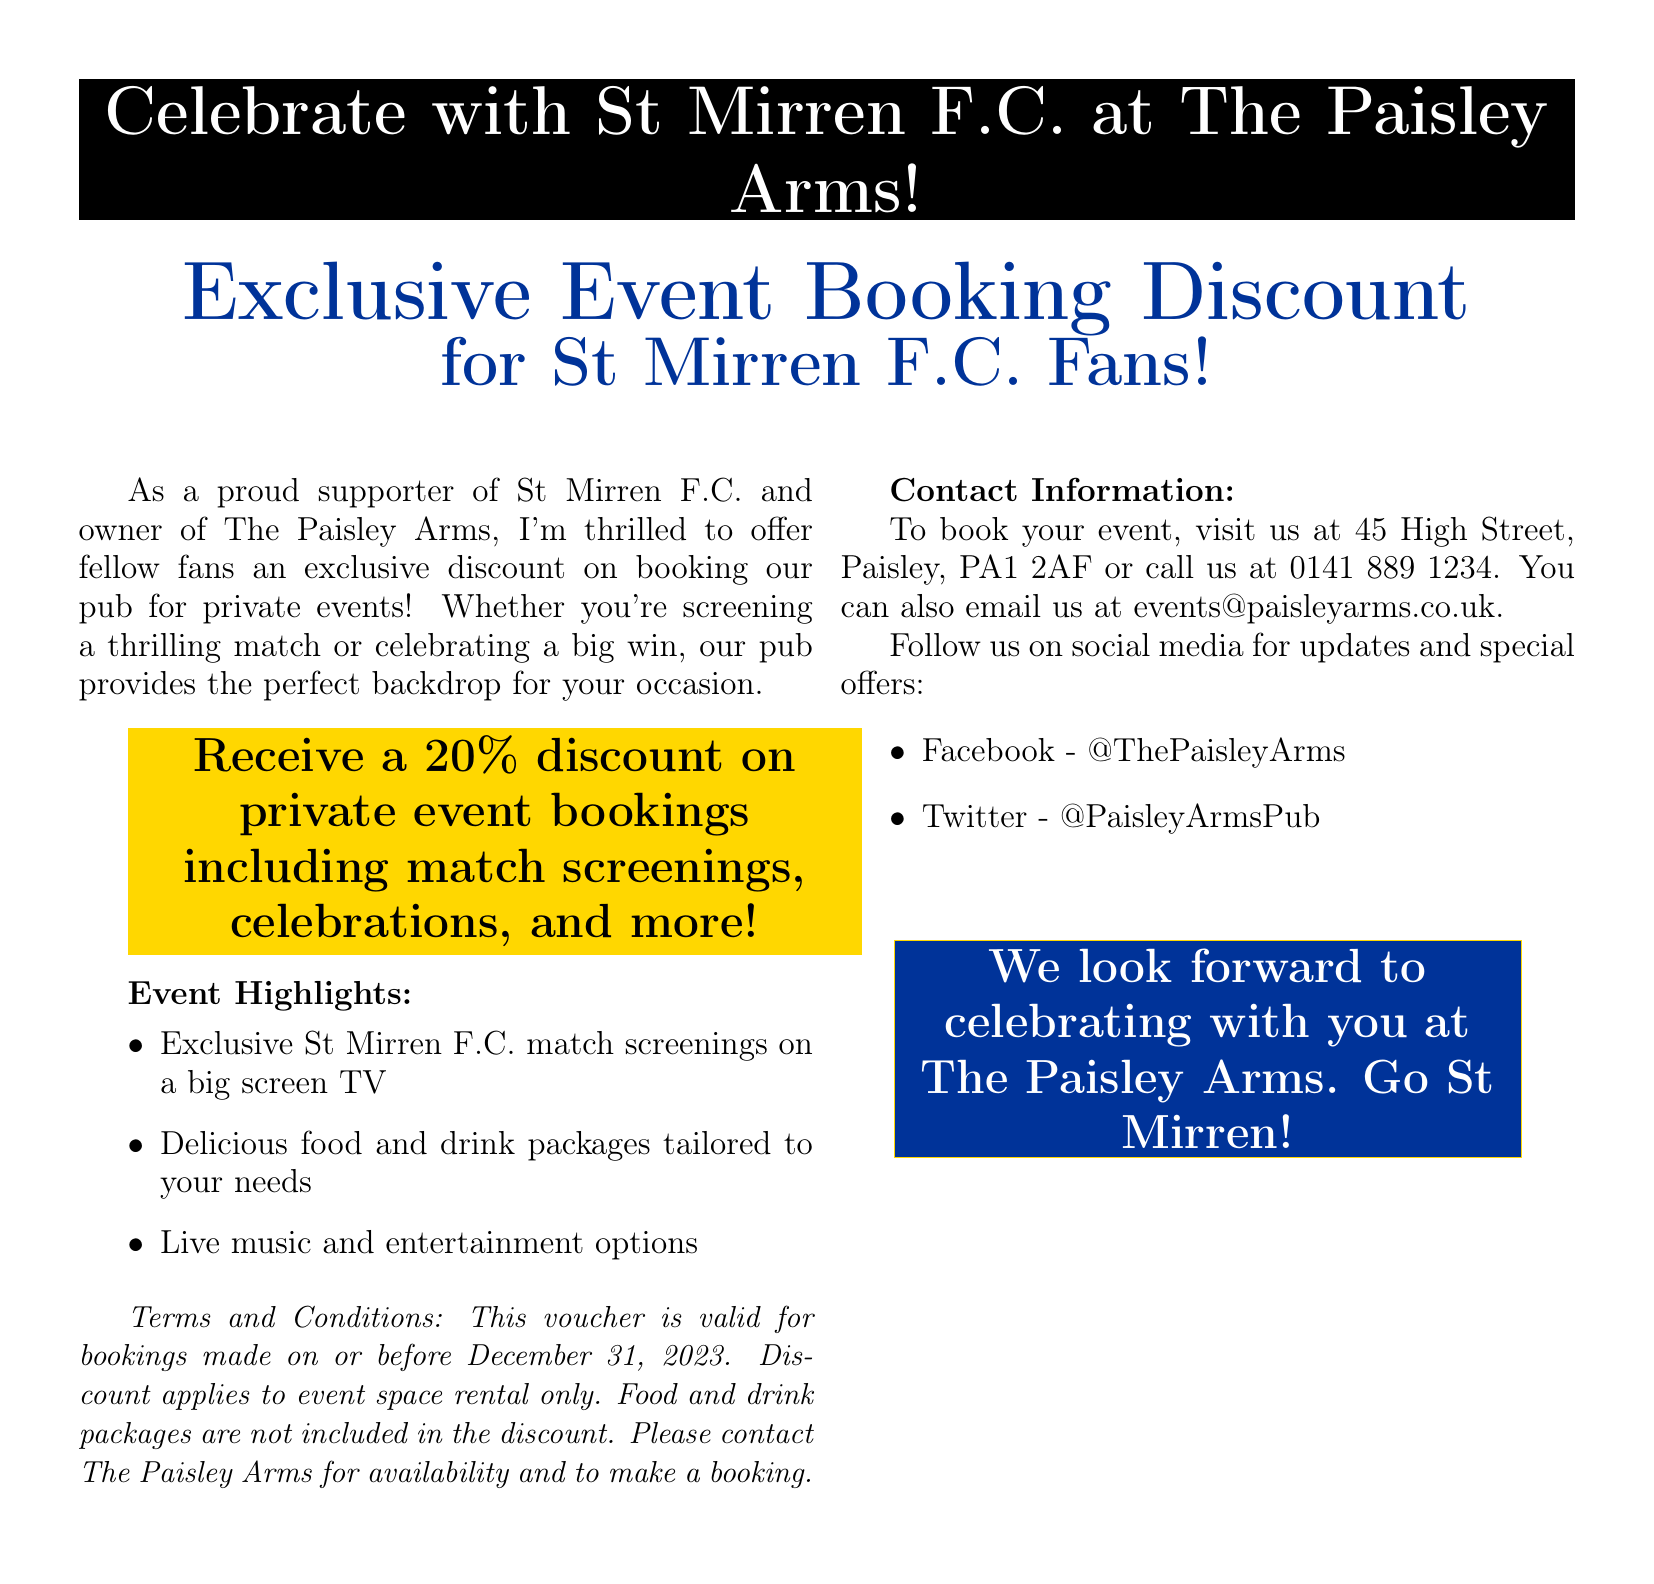What is the name of the pub? The document mentions the pub's name as "The Paisley Arms."
Answer: The Paisley Arms What is the discount percentage on private event bookings? The document states that the discount is "20%."
Answer: 20% What is the last date bookings must be made to use the voucher? According to the document, the voucher is valid for bookings made "on or before December 31, 2023."
Answer: December 31, 2023 Which two types of events are specifically mentioned for booking? The document lists "match screenings" and "celebrations" as types of events.
Answer: match screenings, celebrations What color is used for the trim in the voucher design? The document specifies that the trim color is "gold."
Answer: gold What type of TV is mentioned for the screenings? The document states that there will be a "big screen TV."
Answer: big screen TV What is the address of The Paisley Arms? The document provides the address as "45 High Street, Paisley, PA1 2AF."
Answer: 45 High Street, Paisley, PA1 2AF Where can people follow the pub for updates? The document mentions "Facebook" and "Twitter" as social media platforms to follow.
Answer: Facebook, Twitter What is the main theme of the document? The document is about an "Exclusive Event Booking Discount" for St Mirren F.C. fans.
Answer: Exclusive Event Booking Discount 